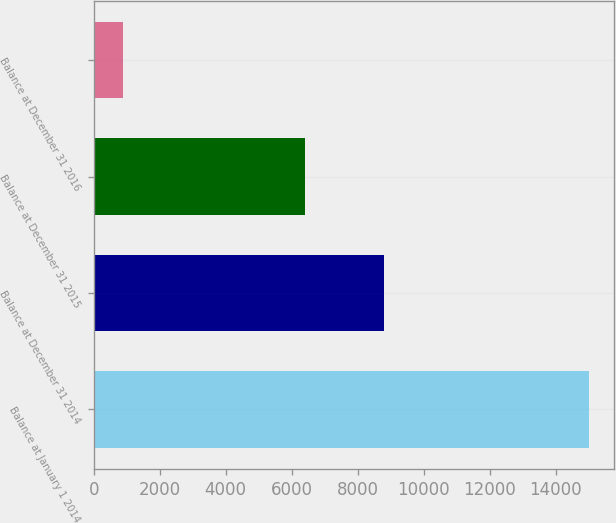Convert chart to OTSL. <chart><loc_0><loc_0><loc_500><loc_500><bar_chart><fcel>Balance at January 1 2014<fcel>Balance at December 31 2014<fcel>Balance at December 31 2015<fcel>Balance at December 31 2016<nl><fcel>14997<fcel>8790<fcel>6397<fcel>877<nl></chart> 